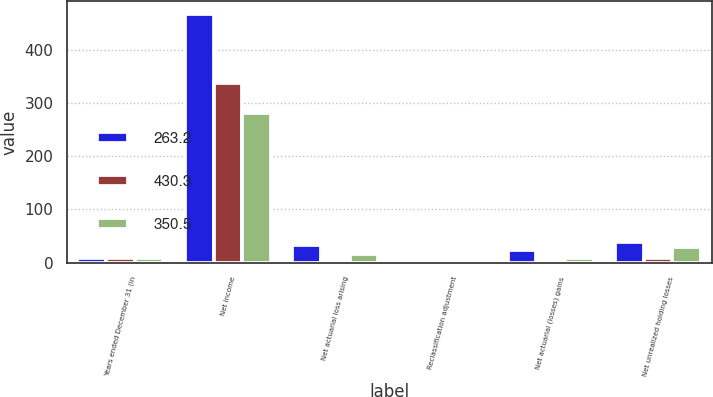Convert chart. <chart><loc_0><loc_0><loc_500><loc_500><stacked_bar_chart><ecel><fcel>Years ended December 31 (in<fcel>Net income<fcel>Net actuarial loss arising<fcel>Reclassification adjustment<fcel>Net actuarial (losses) gains<fcel>Net unrealized holding losses<nl><fcel>263.2<fcel>9.1<fcel>468.1<fcel>32.6<fcel>0.3<fcel>24.3<fcel>38.3<nl><fcel>430.3<fcel>9.1<fcel>337.2<fcel>5.5<fcel>0.8<fcel>3<fcel>8.6<nl><fcel>350.5<fcel>9.1<fcel>281<fcel>15.5<fcel>0.8<fcel>9.1<fcel>29<nl></chart> 